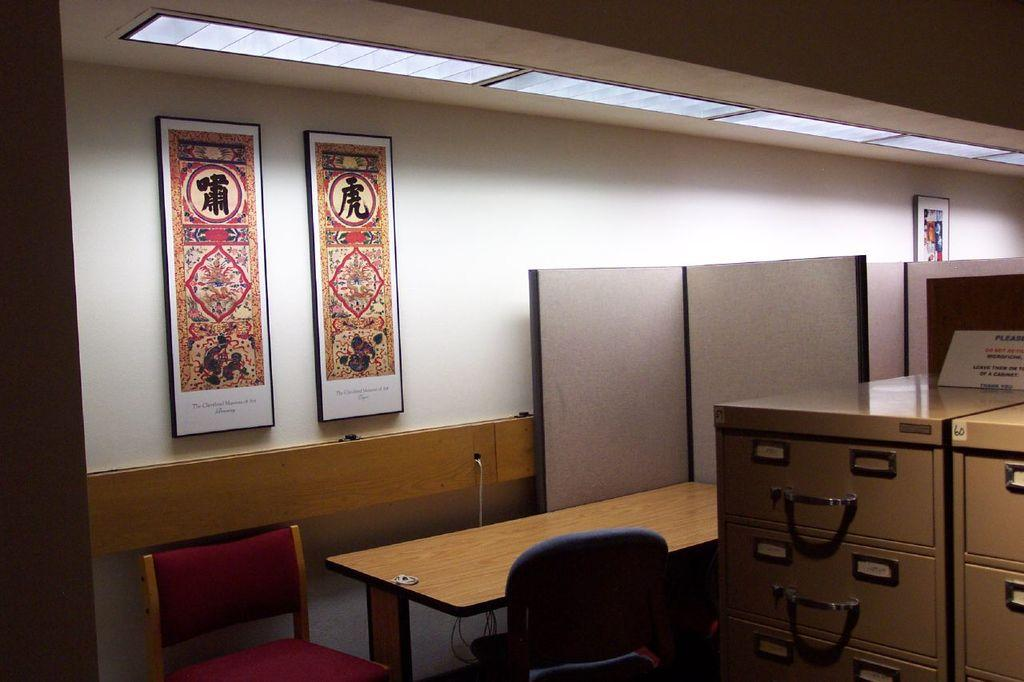What type of space is depicted in the image? There is a room in the image. What furniture is present in the room? There is a table and chairs in the room. What can be seen on the walls of the room? There are frames on the wall in the room. What is the source of light in the room? There is a light in the room. What type of storage is available in the room? There are cupboards in the room. What type of powder is being used in the fight scene in the image? There is no fight scene or powder present in the image; it depicts a room with various objects and furniture. 